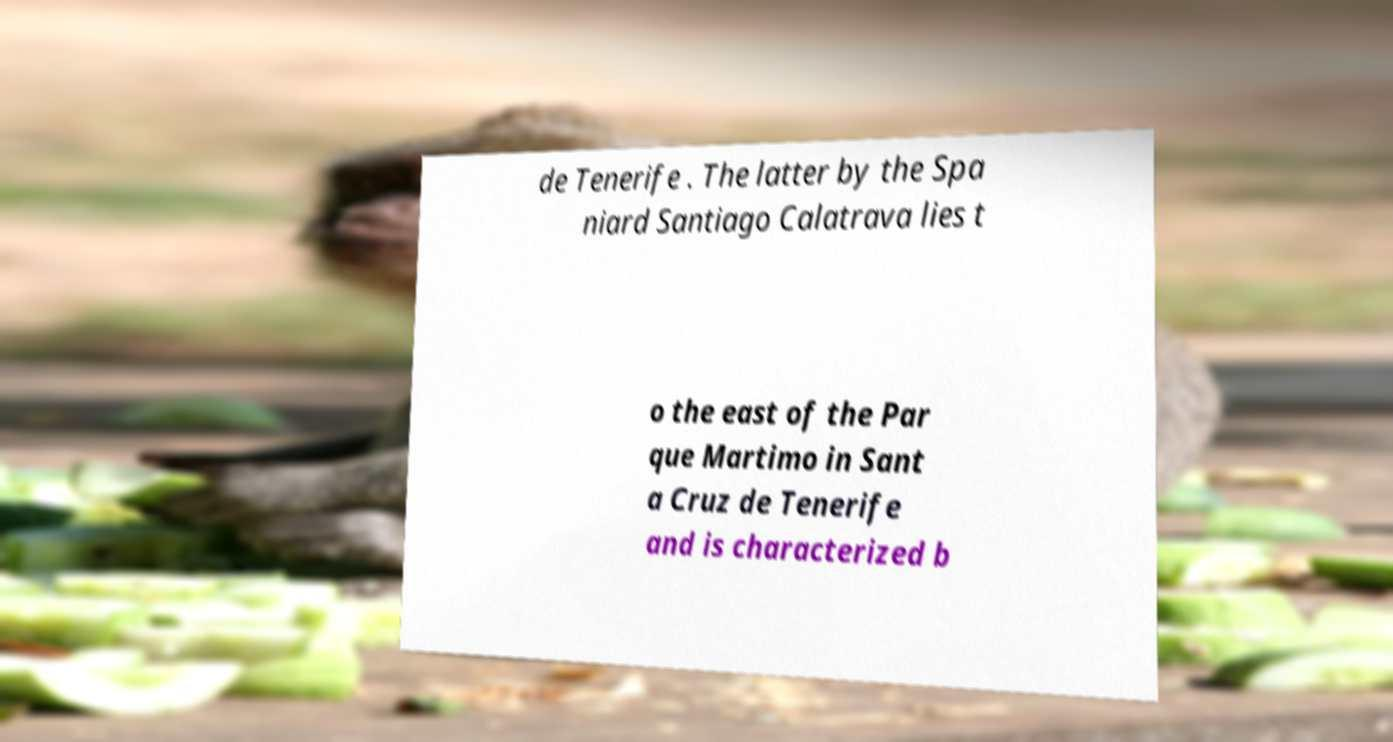There's text embedded in this image that I need extracted. Can you transcribe it verbatim? de Tenerife . The latter by the Spa niard Santiago Calatrava lies t o the east of the Par que Martimo in Sant a Cruz de Tenerife and is characterized b 